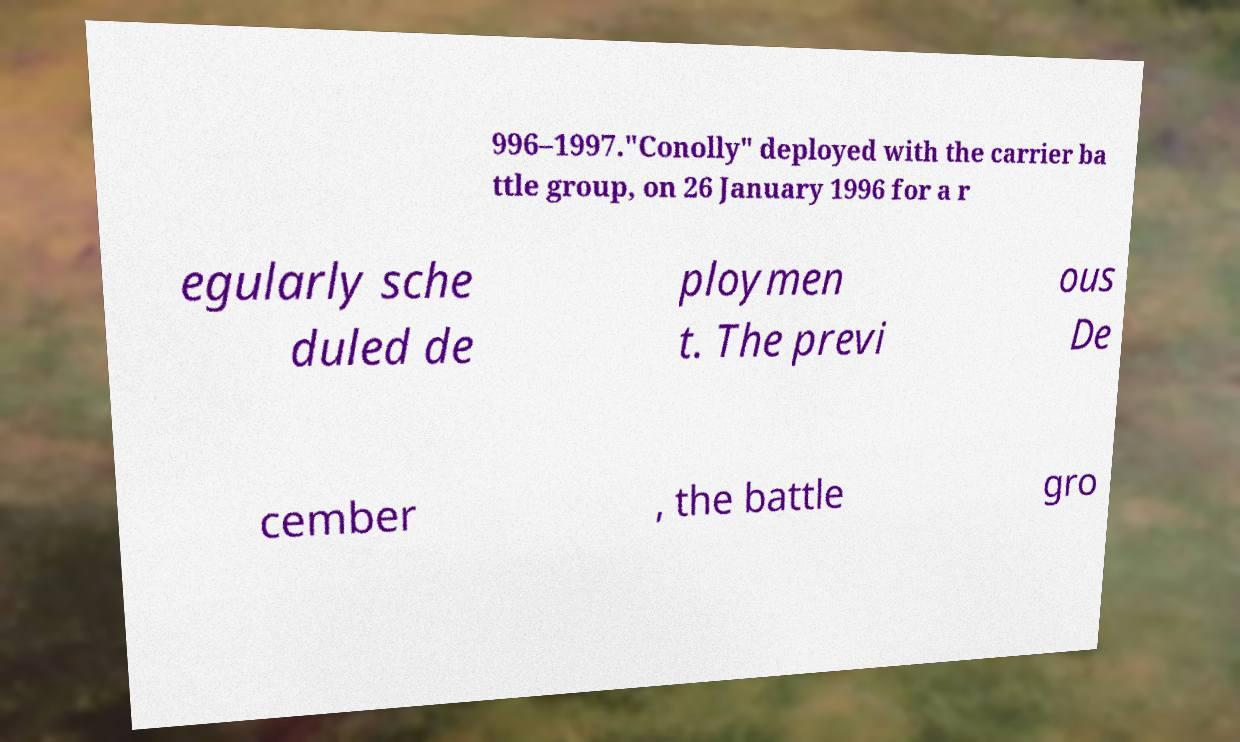Can you accurately transcribe the text from the provided image for me? 996–1997."Conolly" deployed with the carrier ba ttle group, on 26 January 1996 for a r egularly sche duled de ploymen t. The previ ous De cember , the battle gro 